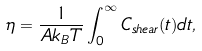Convert formula to latex. <formula><loc_0><loc_0><loc_500><loc_500>\eta = \frac { 1 } { A k _ { B } T } \int _ { 0 } ^ { \infty } C _ { s h e a r } ( t ) d t ,</formula> 